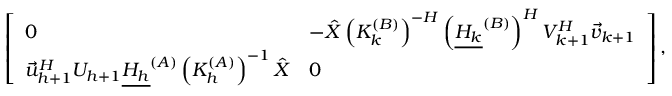Convert formula to latex. <formula><loc_0><loc_0><loc_500><loc_500>\left [ \begin{array} { l l } { 0 } & { - \hat { X } \left ( K _ { k } ^ { ( B ) } \right ) ^ { - H } \left ( \underline { { H _ { k } } } ^ { ( B ) } \right ) ^ { H } V _ { k + 1 } ^ { H } \vec { v } _ { k + 1 } } \\ { \vec { u } _ { h + 1 } ^ { H } U _ { h + 1 } \underline { { H _ { h } } } ^ { ( A ) } \left ( K _ { h } ^ { ( A ) } \right ) ^ { - 1 } \hat { X } } & { 0 } \end{array} \right ] ,</formula> 